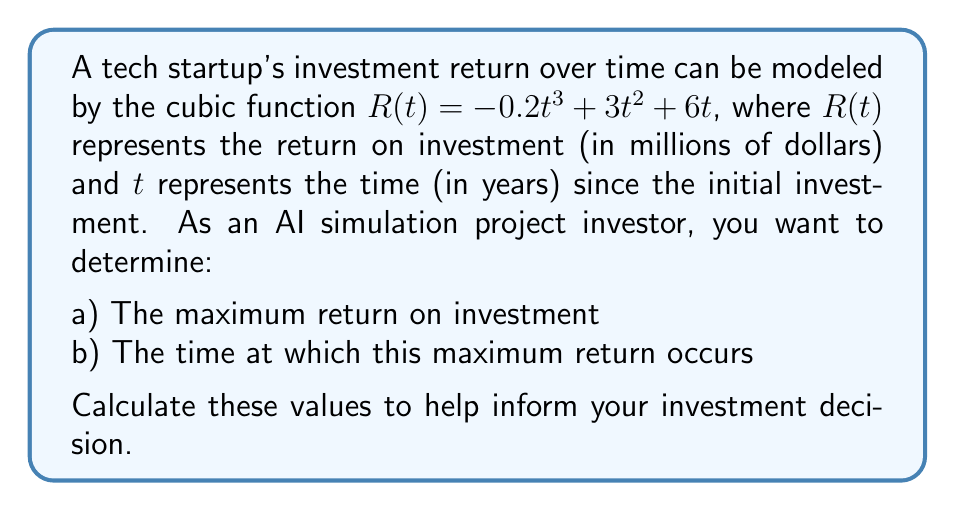Give your solution to this math problem. To solve this problem, we need to follow these steps:

1) Find the derivative of the function $R(t)$:
   $$R'(t) = -0.6t^2 + 6t + 6$$

2) Set the derivative equal to zero to find critical points:
   $$-0.6t^2 + 6t + 6 = 0$$

3) Solve this quadratic equation:
   $$t = \frac{-b \pm \sqrt{b^2 - 4ac}}{2a}$$
   where $a = -0.6$, $b = 6$, and $c = 6$

   $$t = \frac{-6 \pm \sqrt{36 - 4(-0.6)(6)}}{2(-0.6)}$$
   $$t = \frac{-6 \pm \sqrt{50.4}}{-1.2}$$
   $$t = \frac{-6 \pm 7.1}{-1.2}$$

   This gives us two solutions:
   $$t_1 = \frac{-6 + 7.1}{-1.2} \approx 0.92$$
   $$t_2 = \frac{-6 - 7.1}{-1.2} \approx 10.92$$

4) To determine which critical point gives the maximum, we can use the second derivative test:
   $$R''(t) = -1.2t + 6$$
   
   At $t = 0.92$: $R''(0.92) \approx 4.896 > 0$, indicating a local minimum
   At $t = 10.92$: $R''(10.92) \approx -7.104 < 0$, indicating a local maximum

5) Therefore, the maximum return occurs at $t \approx 10.92$ years

6) To find the maximum return, we substitute this value back into the original function:
   $$R(10.92) = -0.2(10.92)^3 + 3(10.92)^2 + 6(10.92)$$
   $$\approx -253.39 + 357.73 + 65.52$$
   $$\approx 169.86$$

Thus, the maximum return on investment is approximately $169.86 million, occurring after about 10.92 years.
Answer: a) The maximum return on investment is approximately $169.86 million.
b) This maximum return occurs after approximately 10.92 years. 